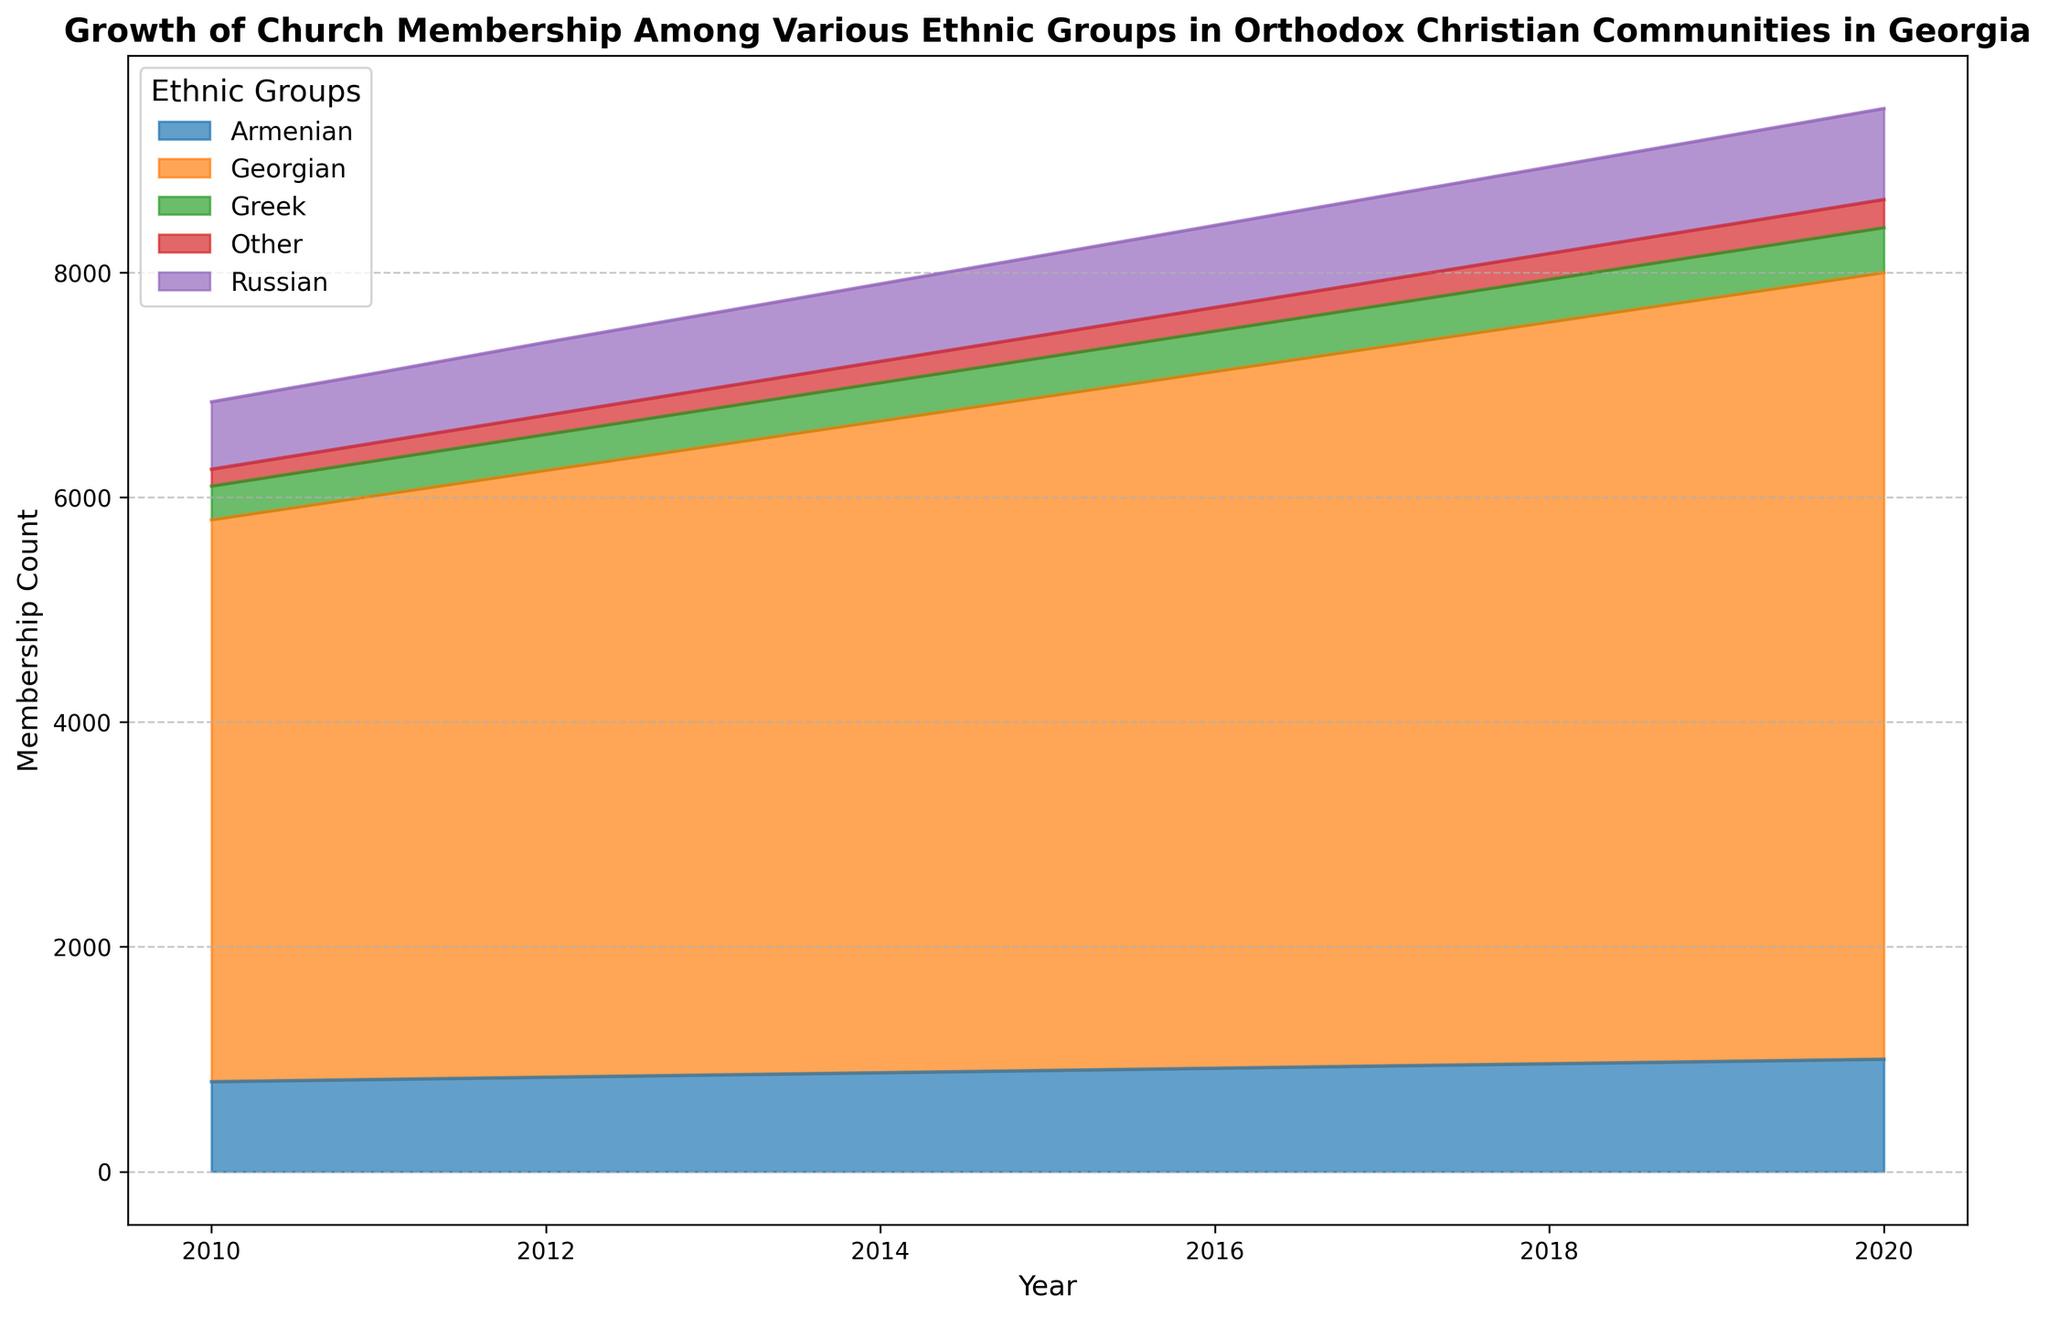What is the overall trend for Georgian church membership from 2010 to 2020? Observe the area chart for the Georgian ethnic group. The height of the area representing the Georgian group increases steadily from 2010 to 2020.
Answer: Increasing Which year had the highest total church membership across all ethnic groups? Visualize the highest stack height in the area chart, which represents the total membership. The stack is highest in 2020.
Answer: 2020 How does the membership count of the Armenian group in 2015 compare to that in 2010? Check the areas representing the Armenian group in both years. The Armenian membership count was 900 in 2015 and 800 in 2010. Therefore, it increased.
Answer: Increased What proportion of the total church membership did the Russian group represent in 2018? Find the total membership for 2018 by summing up the counts of all ethnic groups and then calculate the proportion for Russians. The Russian membership was 770, and the total membership was 8970. Calculate \( \frac{770}{8970} \approx 0.086 \).
Answer: Approximately 8.6% Which ethnic group showed the smallest growth in church membership from 2010 to 2020? Compare the changes in the heights of the areas for each ethnic group from 2010 to 2020. The Greek group's area grew from 300 to 400, which is the smallest numerical increase (100).
Answer: Greek How many total members were there in the year 2011? Sum the membership counts for all ethnic groups in 2011: 5200 (Georgian) + 820 (Armenian) + 620 (Russian) + 310 (Greek) + 160 (Other) = 7110.
Answer: 7110 From 2017 to 2018, which ethnic group had the largest increase in membership count? Observe the change in the height of the respective areas for each ethnic group from 2017 to 2018. The Georgian group increased from 6400 to 6600, which is the largest increase (200 members).
Answer: Georgian Between 2015 and 2020, how did the membership among the 'Other' ethnic groups change? Evaluate the area representing 'Other' for the years 2015 and 2020. The membership increased from 200 in 2015 to 250 in 2020.
Answer: Increased What is the average membership count for the Greek group over the years provided? Add the membership counts for the Greek group from 2010 to 2020 and divide by the number of years (11). \((300 + 310 + 320 + 330 + 340 + 350 + 360 + 370 + 380 + 390 + 400) / 11 = 345\).
Answer: 345 What was the percentage increase in the Georgian church membership from 2010 to 2020? Calculate the percentage increase from 2010's membership to 2020's membership for the Georgian group: \(\frac{7000 - 5000}{5000} \times 100 = 40%\).
Answer: 40% 